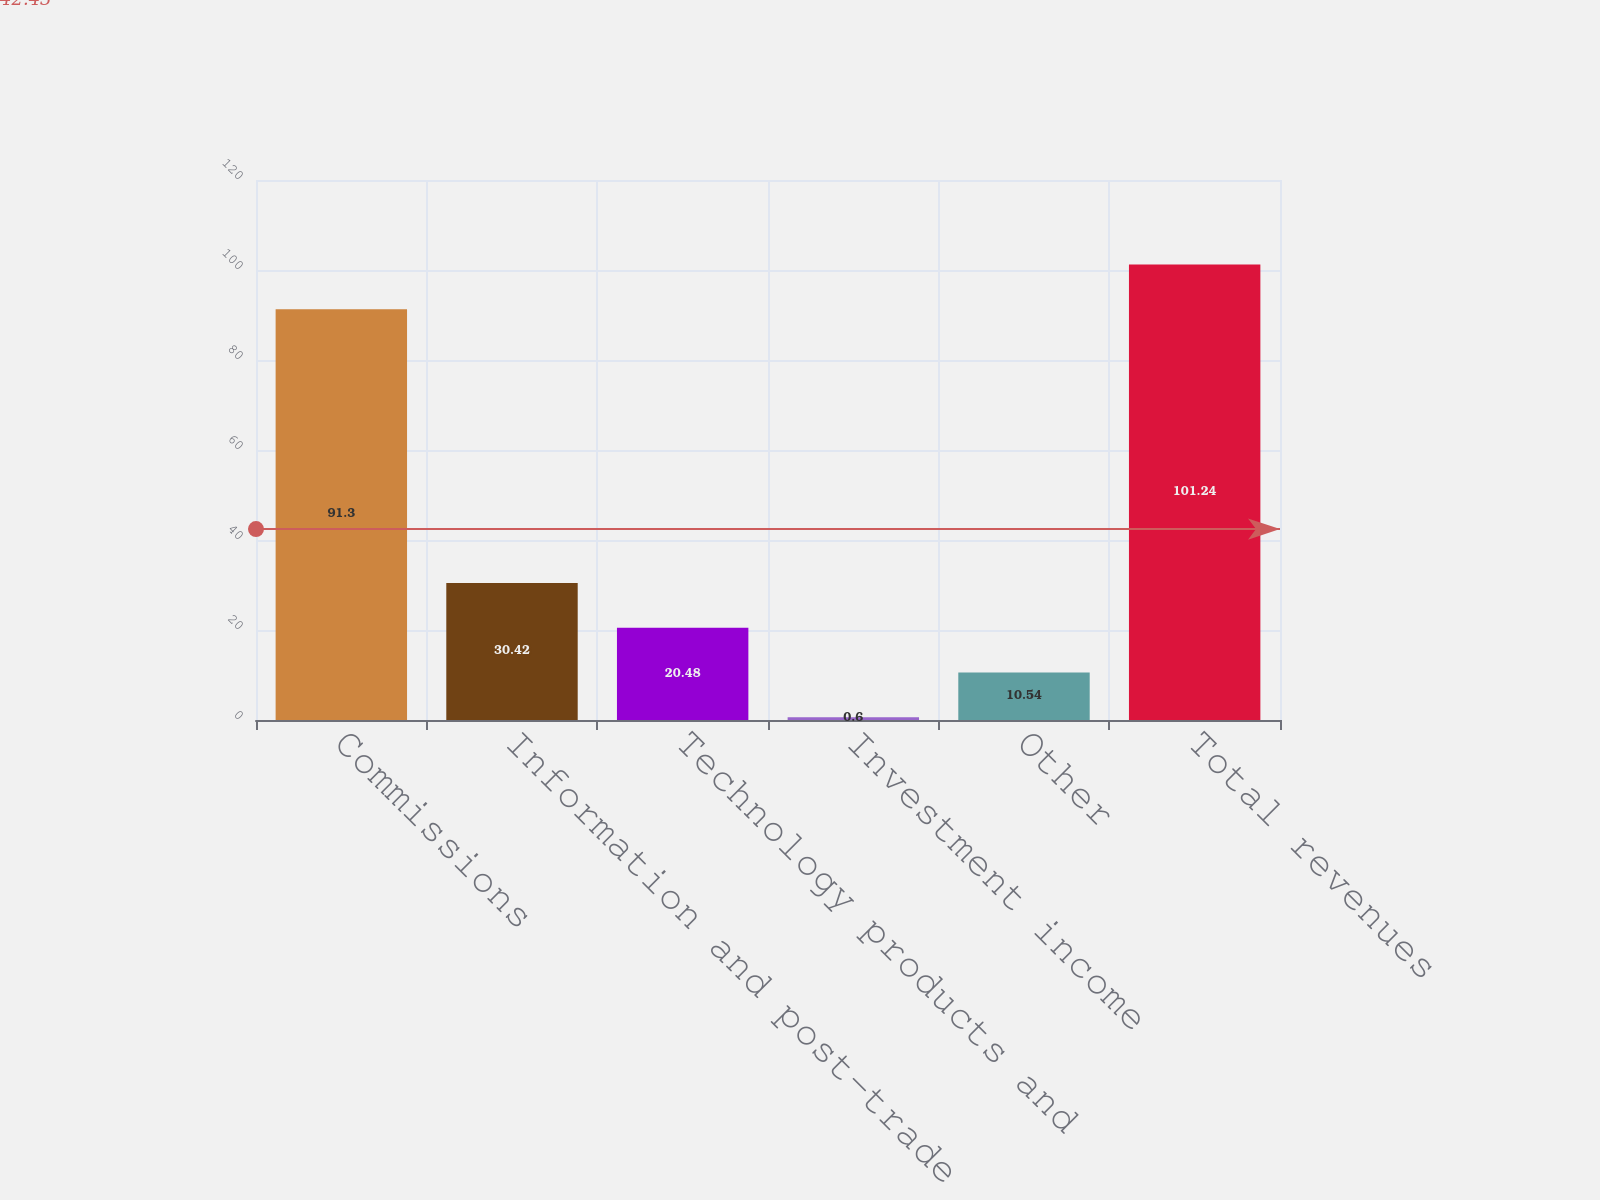Convert chart to OTSL. <chart><loc_0><loc_0><loc_500><loc_500><bar_chart><fcel>Commissions<fcel>Information and post-trade<fcel>Technology products and<fcel>Investment income<fcel>Other<fcel>Total revenues<nl><fcel>91.3<fcel>30.42<fcel>20.48<fcel>0.6<fcel>10.54<fcel>101.24<nl></chart> 